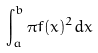<formula> <loc_0><loc_0><loc_500><loc_500>\int _ { a } ^ { b } \pi f ( x ) ^ { 2 } d x</formula> 